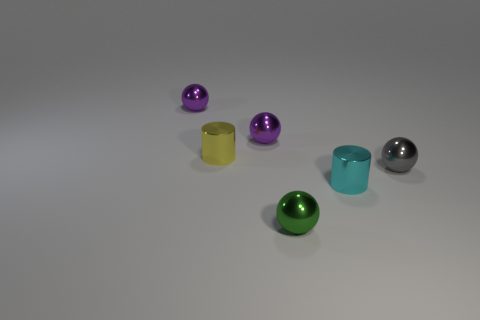Is there any other thing that is the same size as the cyan metal cylinder?
Offer a very short reply. Yes. What number of objects are either yellow cylinders or metal objects to the right of the green metallic sphere?
Offer a very short reply. 3. Is the size of the green metallic object the same as the cylinder behind the gray shiny thing?
Ensure brevity in your answer.  Yes. What color is the other shiny thing that is the same shape as the yellow metal object?
Give a very brief answer. Cyan. Do the yellow shiny cylinder and the cyan cylinder have the same size?
Make the answer very short. Yes. Are there an equal number of yellow metal things that are in front of the yellow metallic thing and small objects?
Keep it short and to the point. No. There is a small purple shiny object that is on the right side of the small yellow object; is there a tiny purple sphere to the left of it?
Make the answer very short. Yes. There is a shiny sphere in front of the tiny shiny ball on the right side of the small cylinder that is in front of the gray object; what is its size?
Your answer should be compact. Small. Is there another thing that has the same shape as the small yellow object?
Offer a terse response. Yes. What is the shape of the green metallic thing?
Keep it short and to the point. Sphere. 